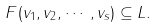Convert formula to latex. <formula><loc_0><loc_0><loc_500><loc_500>F ( v _ { 1 } , v _ { 2 } , \cdots , v _ { s } ) \subseteq L .</formula> 